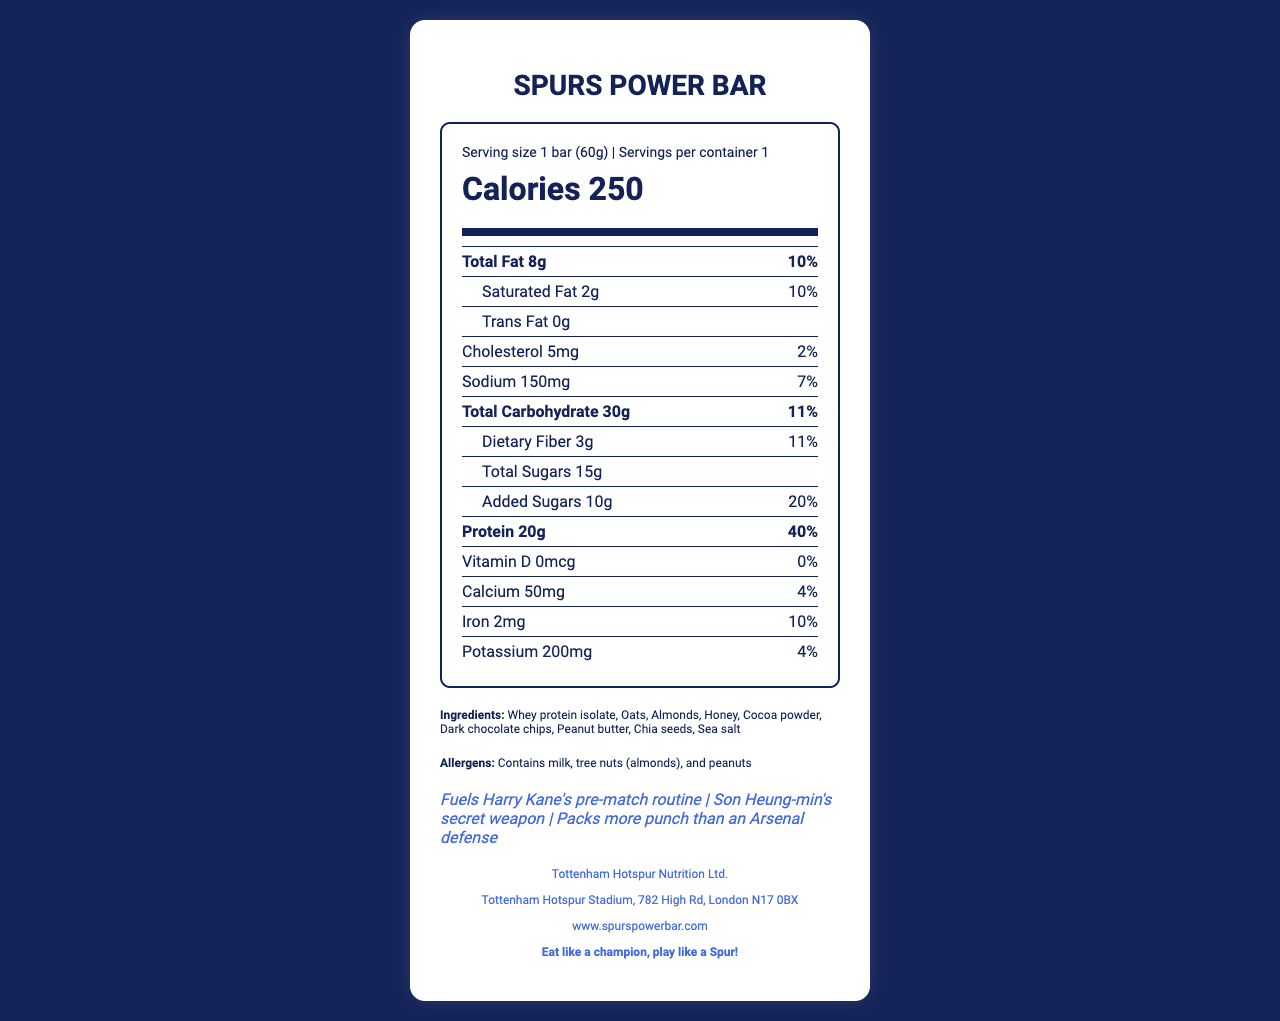what is the serving size of the Spurs Power Bar? The serving size is explicitly stated as "1 bar (60g)" in the document.
Answer: 1 bar (60g) how many calories are in one serving of the Spurs Power Bar? The document lists the calories as 250 in one serving.
Answer: 250 what is the amount of protein in the Spurs Power Bar? According to the document, the protein content in one serving is 20g.
Answer: 20g how much saturated fat does the Spurs Power Bar contain? The amount of saturated fat per serving is 2g as listed in the document.
Answer: 2g what percentage of the daily value of sodium does one serving of the Spurs Power Bar provide? The daily value percentage for sodium is given as 7%.
Answer: 7% what is the total carbohydrate content in the Spurs Power Bar? A. 15g B. 20g C. 30g D. 50g The total carbohydrate content is 30g, as stated in the document.
Answer: C which of the following allergens are present in the Spurs Power Bar? A. Soy B. Tree Nuts C. Gluten D. Eggs The document lists tree nuts (almonds) as one of the allergens.
Answer: B does the Spurs Power Bar contain any trans fat? The document clearly states that there are 0g of trans fat in the Spurs Power Bar.
Answer: No is Vitamin D present in the Spurs Power Bar? The document indicates that Vitamin D content is 0mcg which translates to 0% of the daily value.
Answer: No summarize the nutritional information and claims of the Spurs Power Bar. This summary gathers all major nutritional components and highlights the product's claims, giving a comprehensive overview of the document.
Answer: The Spurs Power Bar is a protein-rich snack with 250 calories per serving and contains 20g of protein, 8g of total fat, 2g of saturated fat, no trans fat, 5mg of cholesterol, 150mg of sodium, 30g of total carbohydrates, 3g of dietary fiber, 15g of total sugars, and 10g of added sugars. It includes ingredients like whey protein isolate, oats, almonds, and peanut butter. The product claims to fuel Harry Kane's pre-match routine and is Son Heung-min's secret weapon. how much calcium is present in the Spurs Power Bar, and what percentage of the daily value does this contribute? The document lists calcium as 50mg and states it contributes to 4% of the daily value.
Answer: 50mg, 4% what is the main ingredient in the Spurs Power Bar? The document lists whey protein isolate as the first ingredient, typically indicating it is the primary ingredient.
Answer: Whey protein isolate which player uses the Spurs Power Bar as his secret weapon according to the claims? A. Harry Kane B. Eric Dier C. Son Heung-min D. Dele Alli The document claims that the Spurs Power Bar is Son Heung-min's secret weapon.
Answer: C how much iron is in the Spurs Power Bar? The document specifies that the iron content is 2mg.
Answer: 2mg where is the manufacturer of the Spurs Power Bar located? The manufacturer's address is provided as Tottenham Hotspur Stadium, 782 High Rd, London N17 0BX.
Answer: Tottenham Hotspur Stadium, 782 High Rd, London N17 0BX is the Spurs Power Bar suitable for someone with a peanut allergy? The document indicates that the product contains peanuts as an allergen.
Answer: No what is the daily value percentage of protein provided by one serving of the Spurs Power Bar? The document lists the daily value percentage for protein as 40%.
Answer: 40% who manufactures the Spurs Power Bar? The document specifies that Tottenham Hotspur Nutrition Ltd. is the manufacturer.
Answer: Tottenham Hotspur Nutrition Ltd. what is the slogan of the Spurs Power Bar? The slogan is "Eat like a champion, play like a Spur!" as stated in the document.
Answer: Eat like a champion, play like a Spur! what is the address of the Spurs Power Bar website? The website address provided in the document is www.spurspowerbar.com.
Answer: www.spurspowerbar.com how much sodium is in one serving of the Spurs Power Bar? The sodium content per serving is listed as 150mg.
Answer: 150mg 